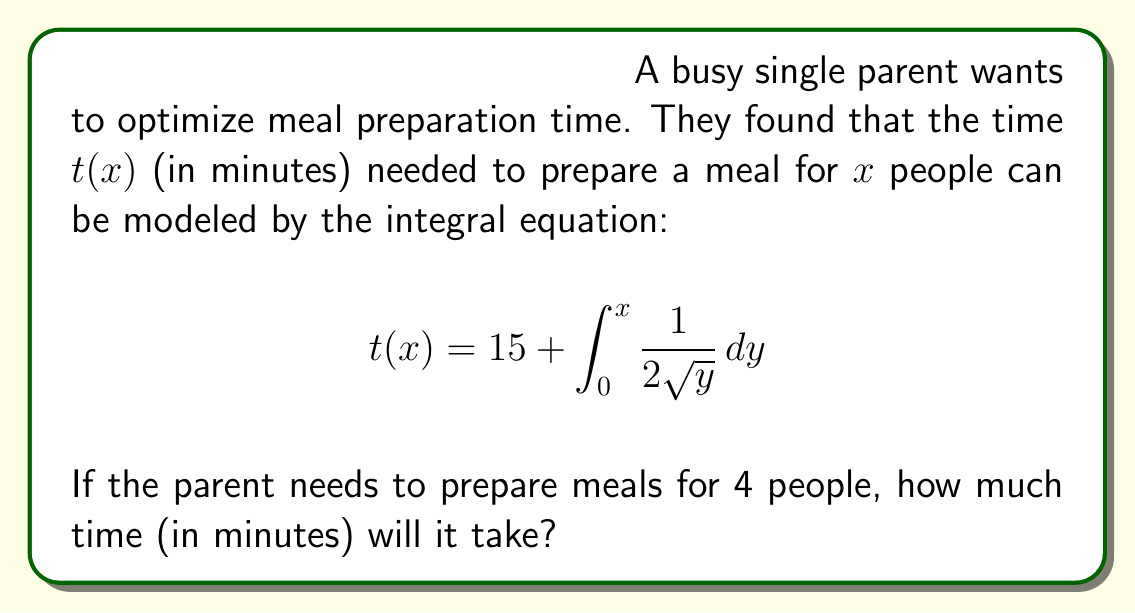Teach me how to tackle this problem. To solve this problem, we need to follow these steps:

1) First, let's solve the integral inside the equation:
   $$\int_0^x \frac{1}{2\sqrt{y}} dy$$

2) We can solve this using the power rule of integration:
   $$\int \frac{1}{2\sqrt{y}} dy = \int y^{-1/2} \cdot \frac{1}{2} dy = \frac{1}{2} \cdot \frac{y^{1/2}}{1/2} + C = y^{1/2} + C$$

3) Now, let's apply the limits:
   $$[y^{1/2}]_0^x = x^{1/2} - 0^{1/2} = x^{1/2}$$

4) So our integral equation becomes:
   $$t(x) = 15 + x^{1/2}$$

5) We need to find $t(4)$, so let's substitute $x = 4$:
   $$t(4) = 15 + 4^{1/2} = 15 + 2 = 17$$

Therefore, it will take 17 minutes to prepare a meal for 4 people.
Answer: 17 minutes 